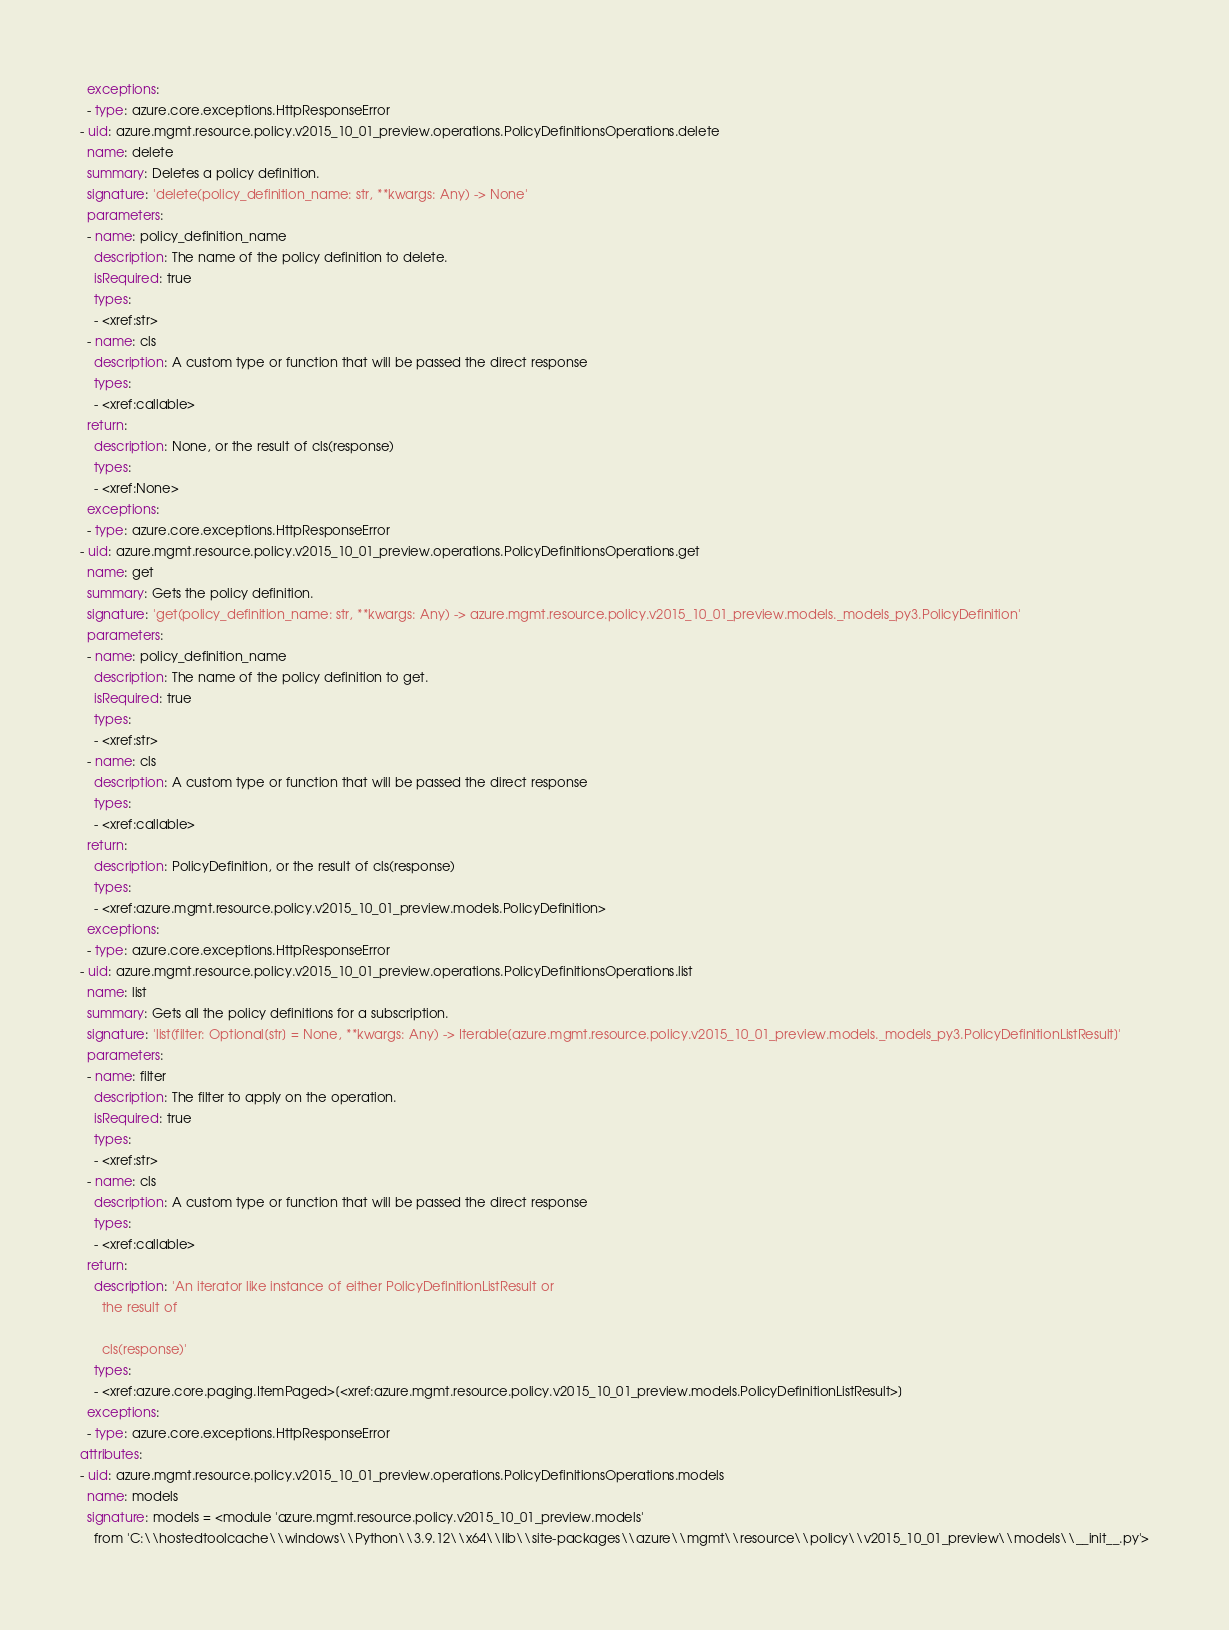Convert code to text. <code><loc_0><loc_0><loc_500><loc_500><_YAML_>  exceptions:
  - type: azure.core.exceptions.HttpResponseError
- uid: azure.mgmt.resource.policy.v2015_10_01_preview.operations.PolicyDefinitionsOperations.delete
  name: delete
  summary: Deletes a policy definition.
  signature: 'delete(policy_definition_name: str, **kwargs: Any) -> None'
  parameters:
  - name: policy_definition_name
    description: The name of the policy definition to delete.
    isRequired: true
    types:
    - <xref:str>
  - name: cls
    description: A custom type or function that will be passed the direct response
    types:
    - <xref:callable>
  return:
    description: None, or the result of cls(response)
    types:
    - <xref:None>
  exceptions:
  - type: azure.core.exceptions.HttpResponseError
- uid: azure.mgmt.resource.policy.v2015_10_01_preview.operations.PolicyDefinitionsOperations.get
  name: get
  summary: Gets the policy definition.
  signature: 'get(policy_definition_name: str, **kwargs: Any) -> azure.mgmt.resource.policy.v2015_10_01_preview.models._models_py3.PolicyDefinition'
  parameters:
  - name: policy_definition_name
    description: The name of the policy definition to get.
    isRequired: true
    types:
    - <xref:str>
  - name: cls
    description: A custom type or function that will be passed the direct response
    types:
    - <xref:callable>
  return:
    description: PolicyDefinition, or the result of cls(response)
    types:
    - <xref:azure.mgmt.resource.policy.v2015_10_01_preview.models.PolicyDefinition>
  exceptions:
  - type: azure.core.exceptions.HttpResponseError
- uid: azure.mgmt.resource.policy.v2015_10_01_preview.operations.PolicyDefinitionsOperations.list
  name: list
  summary: Gets all the policy definitions for a subscription.
  signature: 'list(filter: Optional[str] = None, **kwargs: Any) -> Iterable[azure.mgmt.resource.policy.v2015_10_01_preview.models._models_py3.PolicyDefinitionListResult]'
  parameters:
  - name: filter
    description: The filter to apply on the operation.
    isRequired: true
    types:
    - <xref:str>
  - name: cls
    description: A custom type or function that will be passed the direct response
    types:
    - <xref:callable>
  return:
    description: 'An iterator like instance of either PolicyDefinitionListResult or
      the result of

      cls(response)'
    types:
    - <xref:azure.core.paging.ItemPaged>[<xref:azure.mgmt.resource.policy.v2015_10_01_preview.models.PolicyDefinitionListResult>]
  exceptions:
  - type: azure.core.exceptions.HttpResponseError
attributes:
- uid: azure.mgmt.resource.policy.v2015_10_01_preview.operations.PolicyDefinitionsOperations.models
  name: models
  signature: models = <module 'azure.mgmt.resource.policy.v2015_10_01_preview.models'
    from 'C:\\hostedtoolcache\\windows\\Python\\3.9.12\\x64\\lib\\site-packages\\azure\\mgmt\\resource\\policy\\v2015_10_01_preview\\models\\__init__.py'>
</code> 